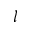<formula> <loc_0><loc_0><loc_500><loc_500>l</formula> 